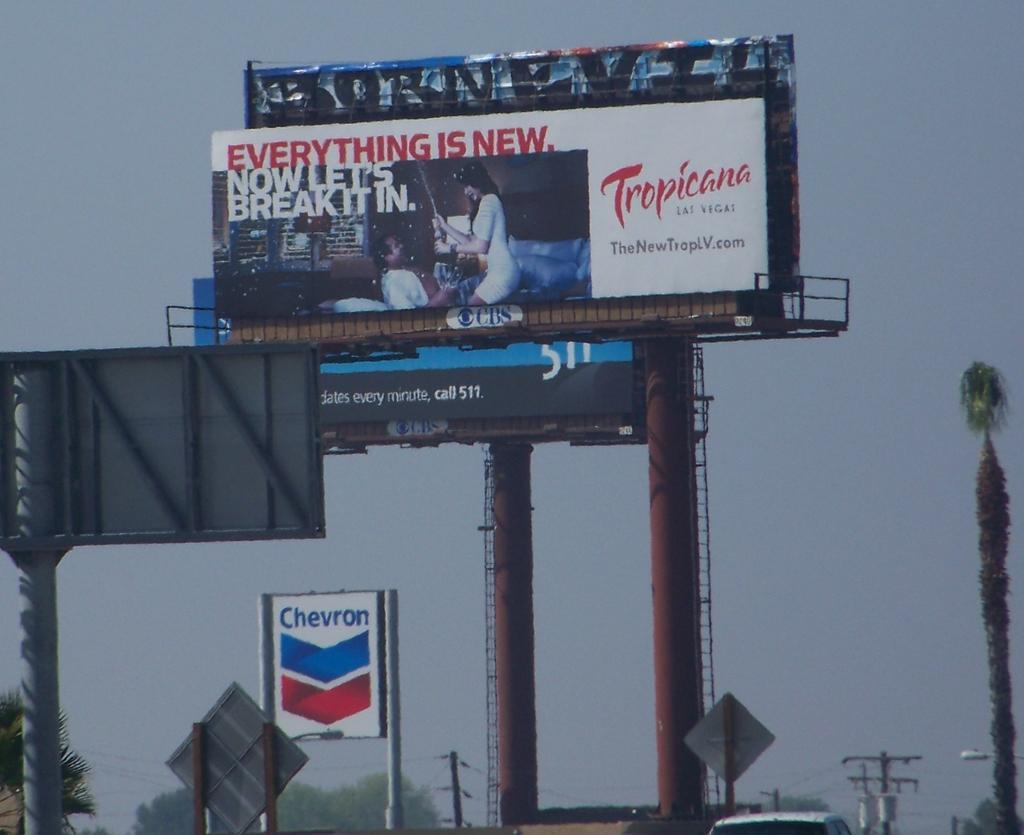Describe this image in one or two sentences. In this image I can see number of poles, number of boards, number of trees and on these boards I can see something is written. On the bottom right side I can see a car and a light. I can also see the sky in the background. 